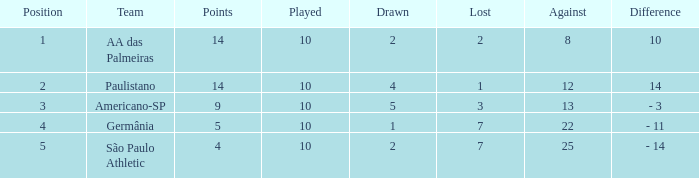What is the lowest Against when the played is more than 10? None. 